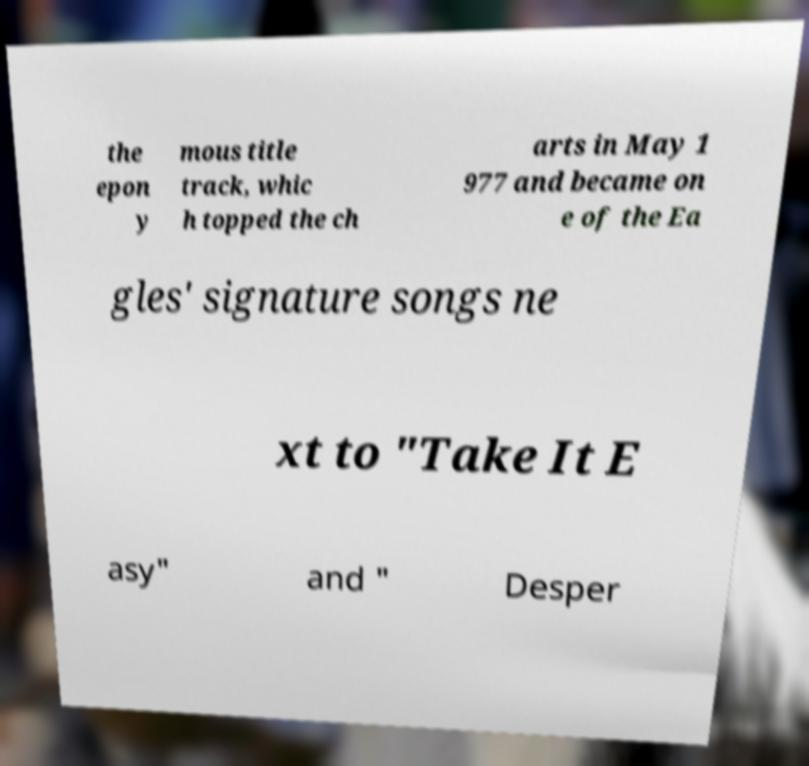Please identify and transcribe the text found in this image. the epon y mous title track, whic h topped the ch arts in May 1 977 and became on e of the Ea gles' signature songs ne xt to "Take It E asy" and " Desper 